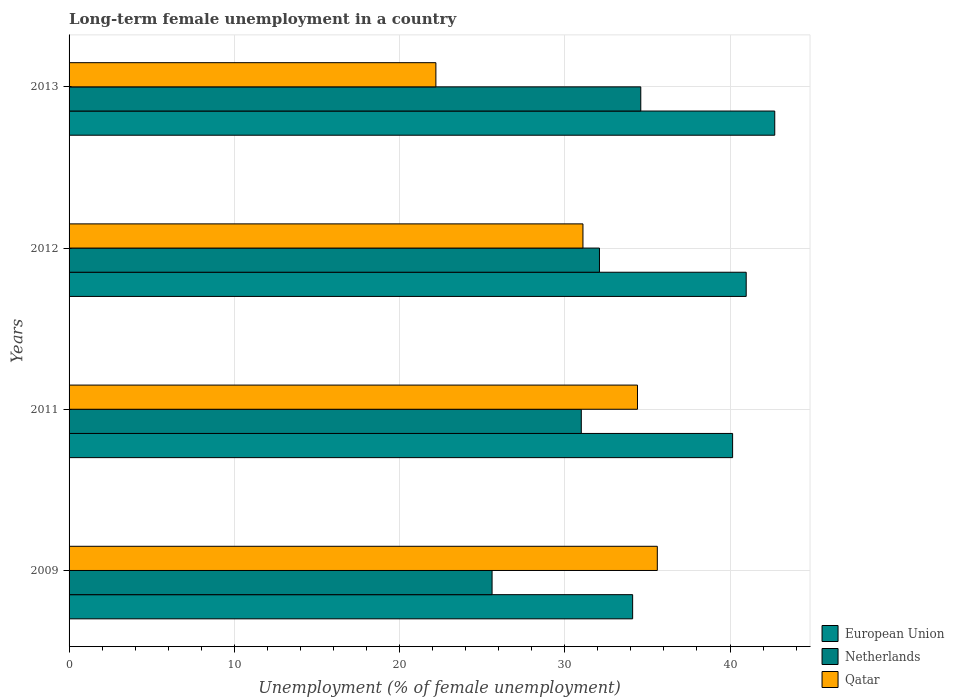How many different coloured bars are there?
Make the answer very short. 3. Are the number of bars per tick equal to the number of legend labels?
Your answer should be very brief. Yes. Are the number of bars on each tick of the Y-axis equal?
Provide a short and direct response. Yes. In how many cases, is the number of bars for a given year not equal to the number of legend labels?
Provide a succinct answer. 0. What is the percentage of long-term unemployed female population in Qatar in 2012?
Your answer should be compact. 31.1. Across all years, what is the maximum percentage of long-term unemployed female population in Netherlands?
Offer a very short reply. 34.6. Across all years, what is the minimum percentage of long-term unemployed female population in Netherlands?
Ensure brevity in your answer.  25.6. What is the total percentage of long-term unemployed female population in Netherlands in the graph?
Your response must be concise. 123.3. What is the difference between the percentage of long-term unemployed female population in European Union in 2009 and that in 2013?
Provide a succinct answer. -8.6. What is the difference between the percentage of long-term unemployed female population in Qatar in 2009 and the percentage of long-term unemployed female population in Netherlands in 2011?
Your response must be concise. 4.6. What is the average percentage of long-term unemployed female population in Netherlands per year?
Give a very brief answer. 30.82. In the year 2009, what is the difference between the percentage of long-term unemployed female population in Qatar and percentage of long-term unemployed female population in European Union?
Ensure brevity in your answer.  1.49. What is the ratio of the percentage of long-term unemployed female population in Qatar in 2009 to that in 2012?
Provide a short and direct response. 1.14. Is the percentage of long-term unemployed female population in European Union in 2011 less than that in 2013?
Offer a terse response. Yes. Is the difference between the percentage of long-term unemployed female population in Qatar in 2011 and 2013 greater than the difference between the percentage of long-term unemployed female population in European Union in 2011 and 2013?
Your answer should be very brief. Yes. What is the difference between the highest and the lowest percentage of long-term unemployed female population in Qatar?
Keep it short and to the point. 13.4. Is the sum of the percentage of long-term unemployed female population in Netherlands in 2009 and 2012 greater than the maximum percentage of long-term unemployed female population in Qatar across all years?
Make the answer very short. Yes. What does the 2nd bar from the top in 2011 represents?
Give a very brief answer. Netherlands. Is it the case that in every year, the sum of the percentage of long-term unemployed female population in European Union and percentage of long-term unemployed female population in Netherlands is greater than the percentage of long-term unemployed female population in Qatar?
Offer a terse response. Yes. Are all the bars in the graph horizontal?
Your answer should be very brief. Yes. How many years are there in the graph?
Provide a succinct answer. 4. What is the title of the graph?
Provide a short and direct response. Long-term female unemployment in a country. Does "East Asia (all income levels)" appear as one of the legend labels in the graph?
Give a very brief answer. No. What is the label or title of the X-axis?
Your response must be concise. Unemployment (% of female unemployment). What is the Unemployment (% of female unemployment) in European Union in 2009?
Provide a succinct answer. 34.11. What is the Unemployment (% of female unemployment) of Netherlands in 2009?
Offer a terse response. 25.6. What is the Unemployment (% of female unemployment) in Qatar in 2009?
Provide a short and direct response. 35.6. What is the Unemployment (% of female unemployment) in European Union in 2011?
Provide a succinct answer. 40.16. What is the Unemployment (% of female unemployment) of Qatar in 2011?
Keep it short and to the point. 34.4. What is the Unemployment (% of female unemployment) in European Union in 2012?
Offer a terse response. 40.98. What is the Unemployment (% of female unemployment) of Netherlands in 2012?
Give a very brief answer. 32.1. What is the Unemployment (% of female unemployment) in Qatar in 2012?
Make the answer very short. 31.1. What is the Unemployment (% of female unemployment) in European Union in 2013?
Provide a short and direct response. 42.71. What is the Unemployment (% of female unemployment) in Netherlands in 2013?
Keep it short and to the point. 34.6. What is the Unemployment (% of female unemployment) in Qatar in 2013?
Ensure brevity in your answer.  22.2. Across all years, what is the maximum Unemployment (% of female unemployment) of European Union?
Your answer should be very brief. 42.71. Across all years, what is the maximum Unemployment (% of female unemployment) in Netherlands?
Offer a very short reply. 34.6. Across all years, what is the maximum Unemployment (% of female unemployment) of Qatar?
Provide a succinct answer. 35.6. Across all years, what is the minimum Unemployment (% of female unemployment) in European Union?
Keep it short and to the point. 34.11. Across all years, what is the minimum Unemployment (% of female unemployment) in Netherlands?
Offer a very short reply. 25.6. Across all years, what is the minimum Unemployment (% of female unemployment) in Qatar?
Your response must be concise. 22.2. What is the total Unemployment (% of female unemployment) in European Union in the graph?
Your answer should be very brief. 157.95. What is the total Unemployment (% of female unemployment) of Netherlands in the graph?
Keep it short and to the point. 123.3. What is the total Unemployment (% of female unemployment) of Qatar in the graph?
Offer a very short reply. 123.3. What is the difference between the Unemployment (% of female unemployment) of European Union in 2009 and that in 2011?
Ensure brevity in your answer.  -6.05. What is the difference between the Unemployment (% of female unemployment) of Netherlands in 2009 and that in 2011?
Provide a succinct answer. -5.4. What is the difference between the Unemployment (% of female unemployment) in European Union in 2009 and that in 2012?
Keep it short and to the point. -6.87. What is the difference between the Unemployment (% of female unemployment) of European Union in 2009 and that in 2013?
Offer a very short reply. -8.6. What is the difference between the Unemployment (% of female unemployment) in European Union in 2011 and that in 2012?
Make the answer very short. -0.82. What is the difference between the Unemployment (% of female unemployment) of Netherlands in 2011 and that in 2012?
Ensure brevity in your answer.  -1.1. What is the difference between the Unemployment (% of female unemployment) of European Union in 2011 and that in 2013?
Ensure brevity in your answer.  -2.55. What is the difference between the Unemployment (% of female unemployment) of Netherlands in 2011 and that in 2013?
Offer a very short reply. -3.6. What is the difference between the Unemployment (% of female unemployment) in Qatar in 2011 and that in 2013?
Offer a very short reply. 12.2. What is the difference between the Unemployment (% of female unemployment) of European Union in 2012 and that in 2013?
Give a very brief answer. -1.73. What is the difference between the Unemployment (% of female unemployment) in Netherlands in 2012 and that in 2013?
Ensure brevity in your answer.  -2.5. What is the difference between the Unemployment (% of female unemployment) of European Union in 2009 and the Unemployment (% of female unemployment) of Netherlands in 2011?
Offer a very short reply. 3.11. What is the difference between the Unemployment (% of female unemployment) in European Union in 2009 and the Unemployment (% of female unemployment) in Qatar in 2011?
Offer a very short reply. -0.29. What is the difference between the Unemployment (% of female unemployment) of Netherlands in 2009 and the Unemployment (% of female unemployment) of Qatar in 2011?
Your answer should be very brief. -8.8. What is the difference between the Unemployment (% of female unemployment) in European Union in 2009 and the Unemployment (% of female unemployment) in Netherlands in 2012?
Give a very brief answer. 2.01. What is the difference between the Unemployment (% of female unemployment) of European Union in 2009 and the Unemployment (% of female unemployment) of Qatar in 2012?
Your response must be concise. 3.01. What is the difference between the Unemployment (% of female unemployment) of Netherlands in 2009 and the Unemployment (% of female unemployment) of Qatar in 2012?
Make the answer very short. -5.5. What is the difference between the Unemployment (% of female unemployment) in European Union in 2009 and the Unemployment (% of female unemployment) in Netherlands in 2013?
Offer a very short reply. -0.49. What is the difference between the Unemployment (% of female unemployment) of European Union in 2009 and the Unemployment (% of female unemployment) of Qatar in 2013?
Your answer should be very brief. 11.91. What is the difference between the Unemployment (% of female unemployment) in European Union in 2011 and the Unemployment (% of female unemployment) in Netherlands in 2012?
Offer a terse response. 8.06. What is the difference between the Unemployment (% of female unemployment) in European Union in 2011 and the Unemployment (% of female unemployment) in Qatar in 2012?
Provide a succinct answer. 9.06. What is the difference between the Unemployment (% of female unemployment) in Netherlands in 2011 and the Unemployment (% of female unemployment) in Qatar in 2012?
Offer a terse response. -0.1. What is the difference between the Unemployment (% of female unemployment) of European Union in 2011 and the Unemployment (% of female unemployment) of Netherlands in 2013?
Offer a terse response. 5.56. What is the difference between the Unemployment (% of female unemployment) of European Union in 2011 and the Unemployment (% of female unemployment) of Qatar in 2013?
Provide a short and direct response. 17.96. What is the difference between the Unemployment (% of female unemployment) of European Union in 2012 and the Unemployment (% of female unemployment) of Netherlands in 2013?
Provide a succinct answer. 6.38. What is the difference between the Unemployment (% of female unemployment) in European Union in 2012 and the Unemployment (% of female unemployment) in Qatar in 2013?
Your answer should be compact. 18.78. What is the average Unemployment (% of female unemployment) in European Union per year?
Give a very brief answer. 39.49. What is the average Unemployment (% of female unemployment) of Netherlands per year?
Keep it short and to the point. 30.82. What is the average Unemployment (% of female unemployment) of Qatar per year?
Provide a short and direct response. 30.82. In the year 2009, what is the difference between the Unemployment (% of female unemployment) in European Union and Unemployment (% of female unemployment) in Netherlands?
Ensure brevity in your answer.  8.51. In the year 2009, what is the difference between the Unemployment (% of female unemployment) of European Union and Unemployment (% of female unemployment) of Qatar?
Give a very brief answer. -1.49. In the year 2011, what is the difference between the Unemployment (% of female unemployment) in European Union and Unemployment (% of female unemployment) in Netherlands?
Keep it short and to the point. 9.16. In the year 2011, what is the difference between the Unemployment (% of female unemployment) in European Union and Unemployment (% of female unemployment) in Qatar?
Your answer should be very brief. 5.76. In the year 2012, what is the difference between the Unemployment (% of female unemployment) of European Union and Unemployment (% of female unemployment) of Netherlands?
Provide a succinct answer. 8.88. In the year 2012, what is the difference between the Unemployment (% of female unemployment) of European Union and Unemployment (% of female unemployment) of Qatar?
Provide a succinct answer. 9.88. In the year 2013, what is the difference between the Unemployment (% of female unemployment) of European Union and Unemployment (% of female unemployment) of Netherlands?
Make the answer very short. 8.11. In the year 2013, what is the difference between the Unemployment (% of female unemployment) in European Union and Unemployment (% of female unemployment) in Qatar?
Offer a very short reply. 20.51. In the year 2013, what is the difference between the Unemployment (% of female unemployment) of Netherlands and Unemployment (% of female unemployment) of Qatar?
Ensure brevity in your answer.  12.4. What is the ratio of the Unemployment (% of female unemployment) of European Union in 2009 to that in 2011?
Provide a short and direct response. 0.85. What is the ratio of the Unemployment (% of female unemployment) of Netherlands in 2009 to that in 2011?
Your response must be concise. 0.83. What is the ratio of the Unemployment (% of female unemployment) in Qatar in 2009 to that in 2011?
Offer a terse response. 1.03. What is the ratio of the Unemployment (% of female unemployment) in European Union in 2009 to that in 2012?
Keep it short and to the point. 0.83. What is the ratio of the Unemployment (% of female unemployment) in Netherlands in 2009 to that in 2012?
Give a very brief answer. 0.8. What is the ratio of the Unemployment (% of female unemployment) of Qatar in 2009 to that in 2012?
Offer a terse response. 1.14. What is the ratio of the Unemployment (% of female unemployment) in European Union in 2009 to that in 2013?
Provide a short and direct response. 0.8. What is the ratio of the Unemployment (% of female unemployment) in Netherlands in 2009 to that in 2013?
Offer a terse response. 0.74. What is the ratio of the Unemployment (% of female unemployment) in Qatar in 2009 to that in 2013?
Your answer should be very brief. 1.6. What is the ratio of the Unemployment (% of female unemployment) of European Union in 2011 to that in 2012?
Make the answer very short. 0.98. What is the ratio of the Unemployment (% of female unemployment) of Netherlands in 2011 to that in 2012?
Your answer should be very brief. 0.97. What is the ratio of the Unemployment (% of female unemployment) of Qatar in 2011 to that in 2012?
Make the answer very short. 1.11. What is the ratio of the Unemployment (% of female unemployment) of European Union in 2011 to that in 2013?
Ensure brevity in your answer.  0.94. What is the ratio of the Unemployment (% of female unemployment) of Netherlands in 2011 to that in 2013?
Offer a very short reply. 0.9. What is the ratio of the Unemployment (% of female unemployment) of Qatar in 2011 to that in 2013?
Offer a very short reply. 1.55. What is the ratio of the Unemployment (% of female unemployment) of European Union in 2012 to that in 2013?
Offer a very short reply. 0.96. What is the ratio of the Unemployment (% of female unemployment) in Netherlands in 2012 to that in 2013?
Your answer should be compact. 0.93. What is the ratio of the Unemployment (% of female unemployment) in Qatar in 2012 to that in 2013?
Offer a terse response. 1.4. What is the difference between the highest and the second highest Unemployment (% of female unemployment) in European Union?
Give a very brief answer. 1.73. What is the difference between the highest and the lowest Unemployment (% of female unemployment) of European Union?
Your response must be concise. 8.6. What is the difference between the highest and the lowest Unemployment (% of female unemployment) of Netherlands?
Provide a short and direct response. 9. 